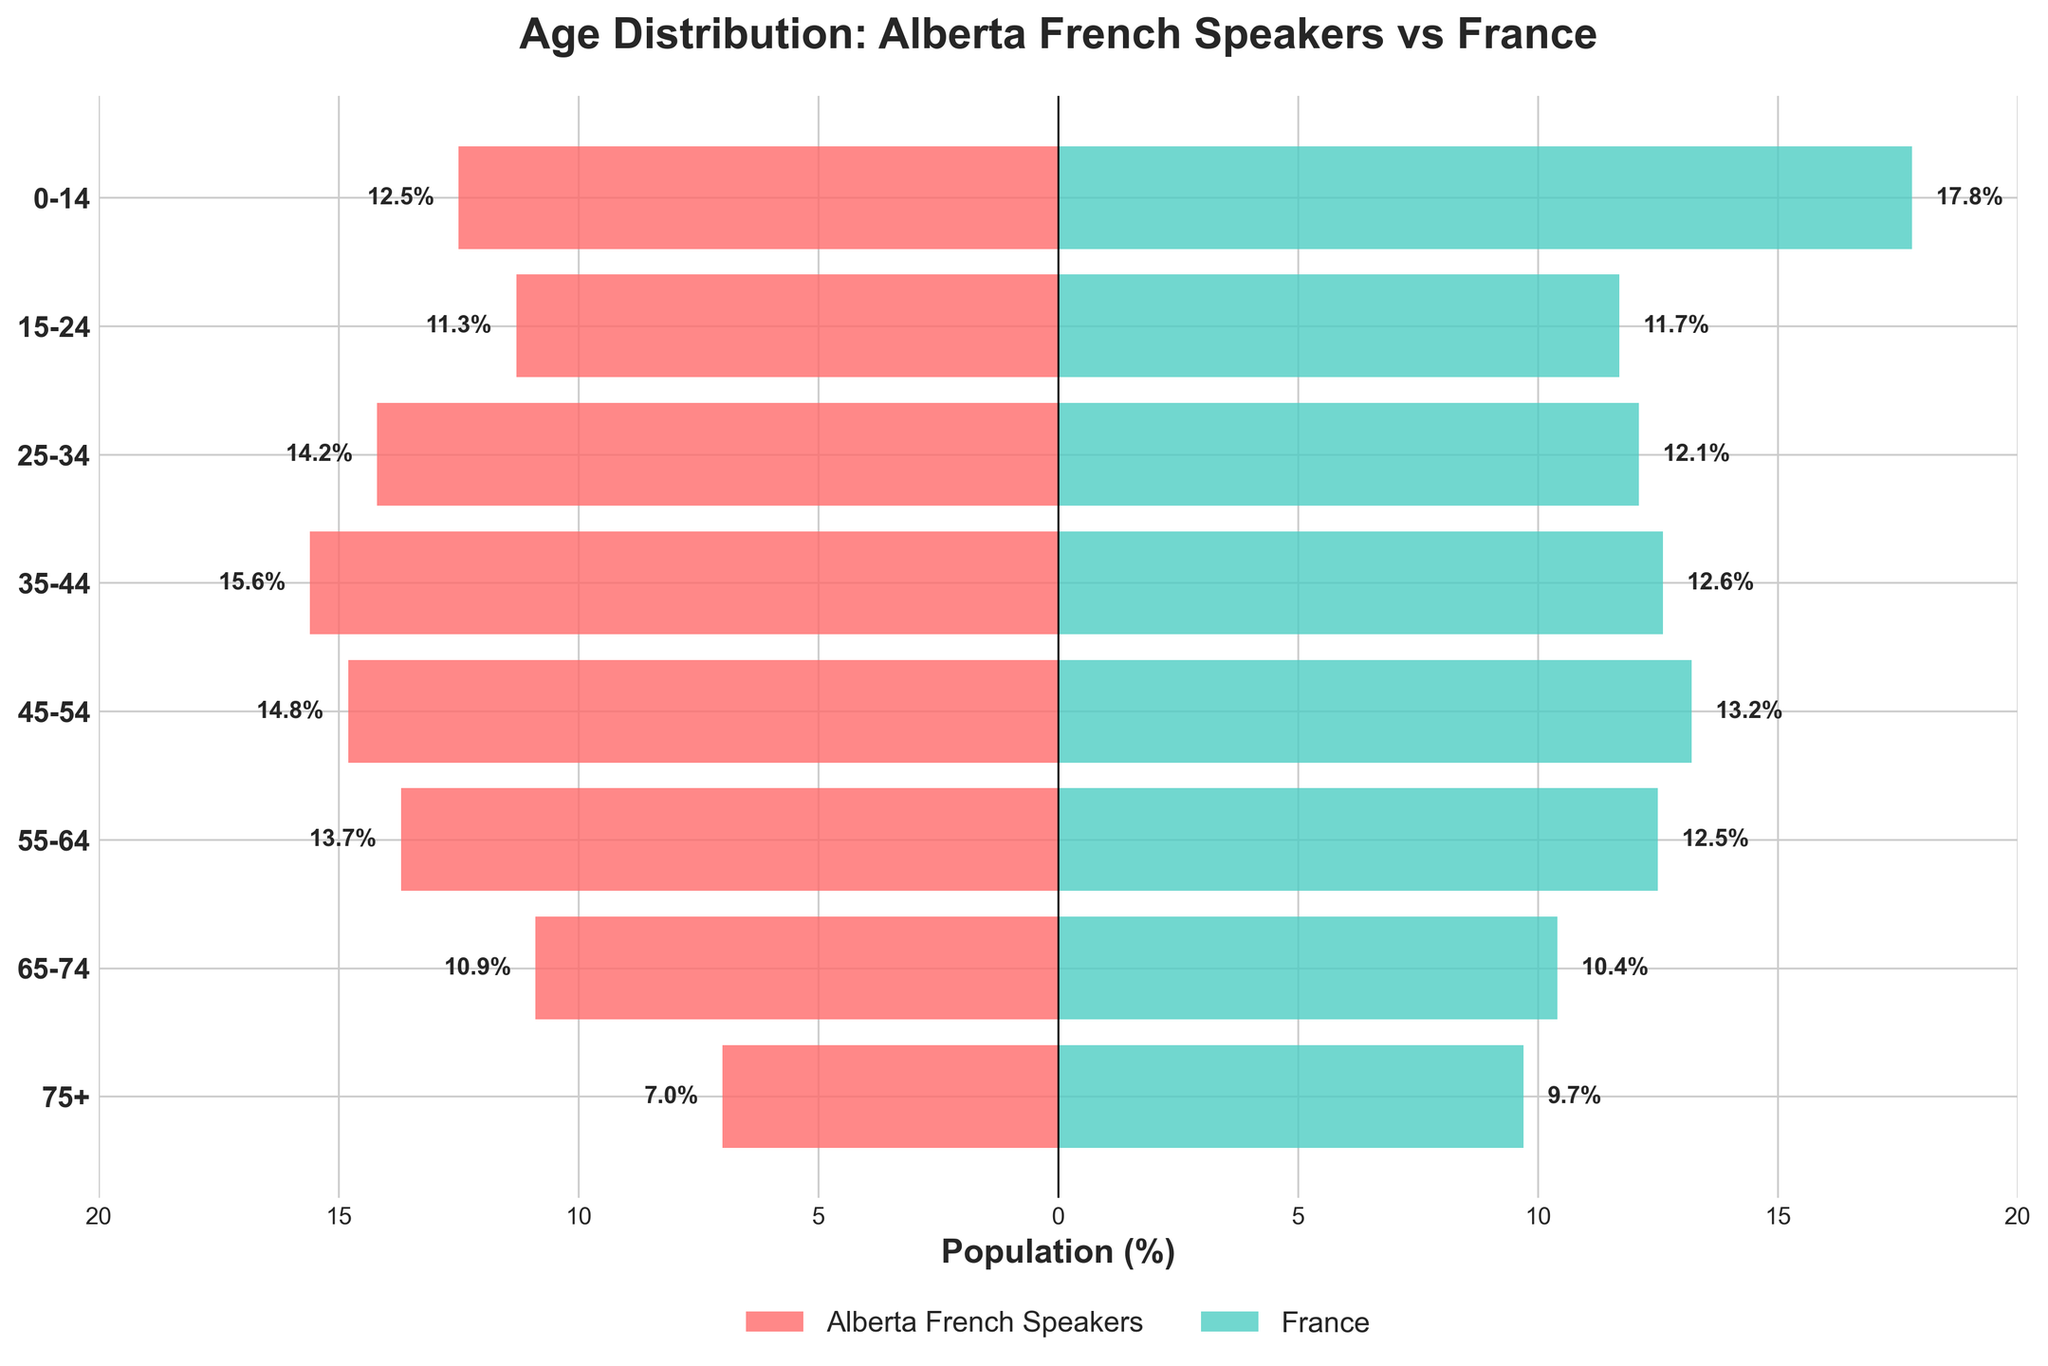What is the title of the figure? The title of the figure is usually displayed at the top and provides a summary of what the figure represents. Here, it states the subject of the comparison.
Answer: Age Distribution: Alberta French Speakers vs France Which age group has the highest percentage in Alberta and France respectively? From the figure, locate the longest bar for Alberta French Speakers and France. The age group with the longest red bar represents Alberta's highest percentage, while the age group with the longest green bar represents France's highest percentage.
Answer: 35-44 (Alberta), 0-14 (France) Which age group has the lowest percentage of Alberta French Speakers? Identify the shortest red bar on the left side of the population pyramid, which indicates the age group with the lowest percentage of Alberta French Speakers.
Answer: 75+ What is the percentage difference between Alberta French Speakers and France in the 0-14 age group? Find the corresponding bars for the 0-14 age group for both Alberta and France. Subtract the percentage of Alberta French Speakers from the percentage of France for this age group.
Answer: 5.3% What is the combined percentage of Alberta French Speakers in the 35-44 and 45-54 age groups? Locate the percentages for both the 35-44 and 45-54 age groups in Alberta, then sum these percentages.
Answer: 30.4% Which age group shows a higher percentage in Alberta French Speakers compared to France? Compare the lengths of the red and green bars for each age group. Identify the age groups where the red bar (Alberta) is longer than the green bar (France).
Answer: 25-34, 35-44, 45-54, 55-64, 65-74 What is the percentage for the 65-74 age group in Alberta and France, and which is higher? Identify the bars corresponding to the 65-74 age group for both Alberta and France. Compare their lengths to determine which is higher.
Answer: Alberta: 10.9%, France: 10.4%, Alberta is higher What is the average percentage of the age groups 25-34, 35-44, and 45-54 in France? Sum the percentages for the age groups 25-34, 35-44, and 45-54 in France, then divide by the number of age groups (3).
Answer: 12.63% How does the percentage of Alberta French Speakers aged 55-64 compare to those aged 15-24? Compare the heights of the bars for the 55-64 and 15-24 age groups on the Alberta side. Identify if the percentage is greater, lesser, or equal.
Answer: 55-64 is greater How many age groups have Alberta French Speakers' percentages between 10% and 15%? Count the bars on the Alberta side that fall within the 10% to 15% range.
Answer: Four 